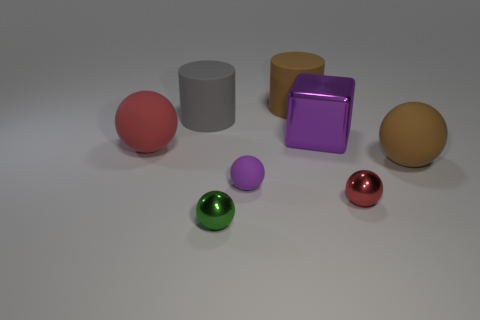Subtract all tiny purple balls. How many balls are left? 4 Add 2 brown cylinders. How many objects exist? 10 Subtract all brown balls. How many balls are left? 4 Subtract all cylinders. How many objects are left? 6 Subtract 1 cylinders. How many cylinders are left? 1 Subtract all purple blocks. How many yellow cylinders are left? 0 Subtract 0 blue spheres. How many objects are left? 8 Subtract all brown cylinders. Subtract all purple balls. How many cylinders are left? 1 Subtract all red metal cylinders. Subtract all balls. How many objects are left? 3 Add 6 brown balls. How many brown balls are left? 7 